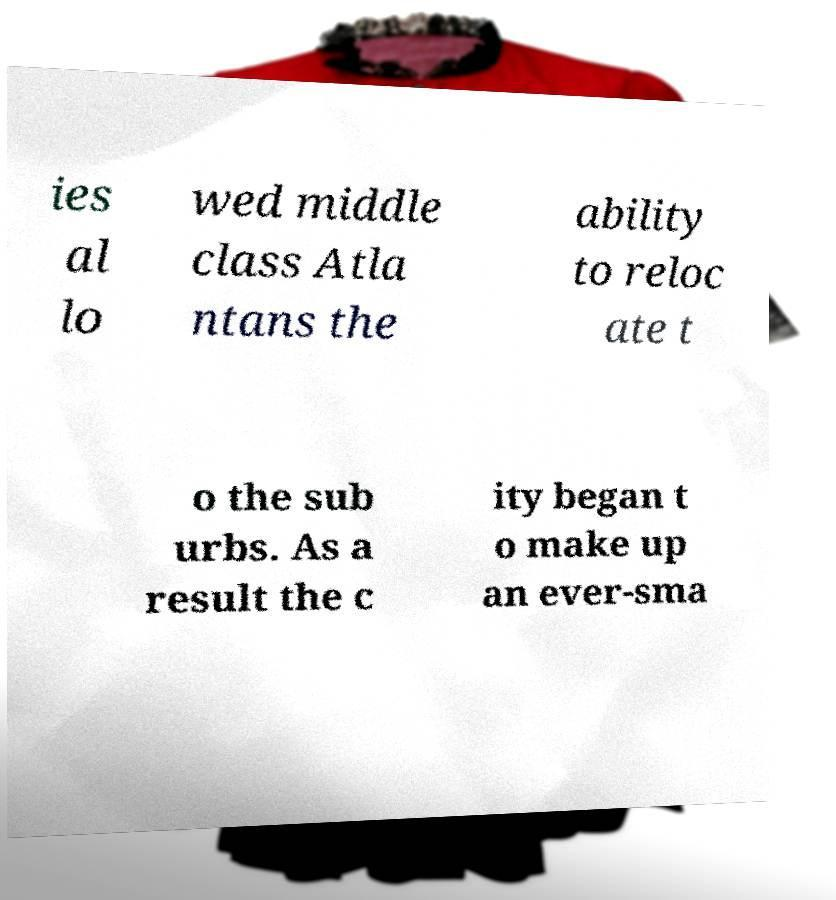What messages or text are displayed in this image? I need them in a readable, typed format. ies al lo wed middle class Atla ntans the ability to reloc ate t o the sub urbs. As a result the c ity began t o make up an ever-sma 